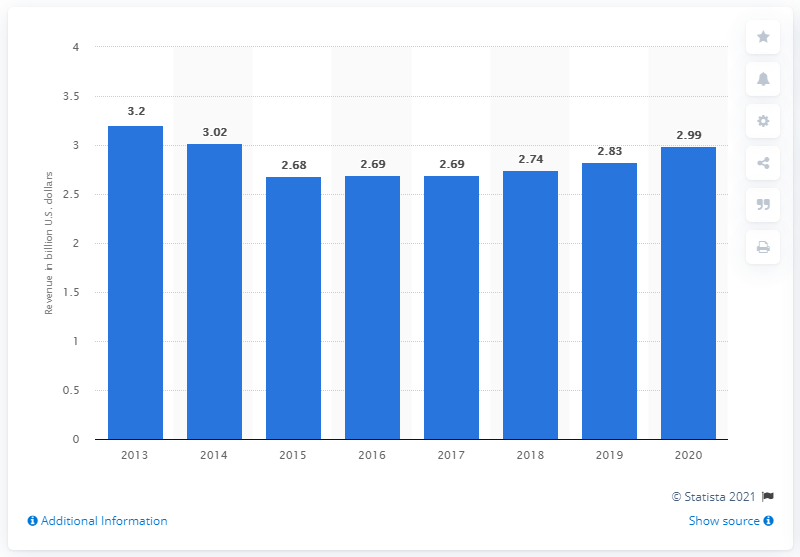Draw attention to some important aspects in this diagram. In 2013, the net revenue of PepsiCo in the United States was 2.83 billion dollars. 